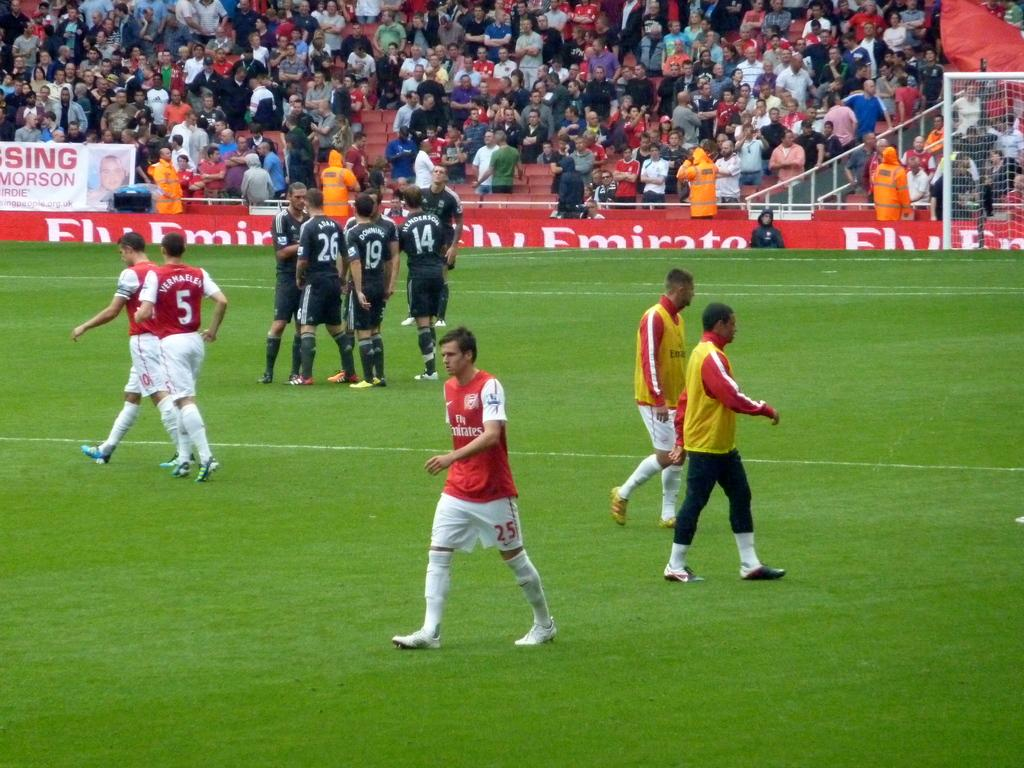<image>
Share a concise interpretation of the image provided. The soccer stadium has banners on the lower walls sponsored by Fly Emirates. 